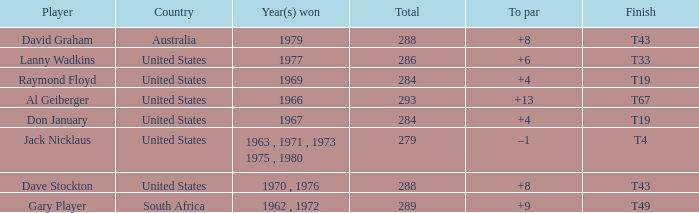What is the average total in 1969? 284.0. 